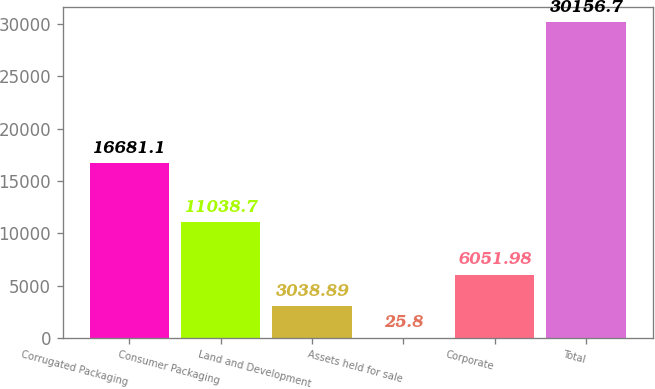Convert chart to OTSL. <chart><loc_0><loc_0><loc_500><loc_500><bar_chart><fcel>Corrugated Packaging<fcel>Consumer Packaging<fcel>Land and Development<fcel>Assets held for sale<fcel>Corporate<fcel>Total<nl><fcel>16681.1<fcel>11038.7<fcel>3038.89<fcel>25.8<fcel>6051.98<fcel>30156.7<nl></chart> 